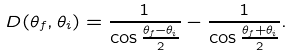Convert formula to latex. <formula><loc_0><loc_0><loc_500><loc_500>D ( \theta _ { f } , \theta _ { i } ) = \frac { 1 } { \cos \frac { \theta _ { f } - \theta _ { i } } { 2 } } - \frac { 1 } { \cos \frac { \theta _ { f } + \theta _ { i } } { 2 } } .</formula> 